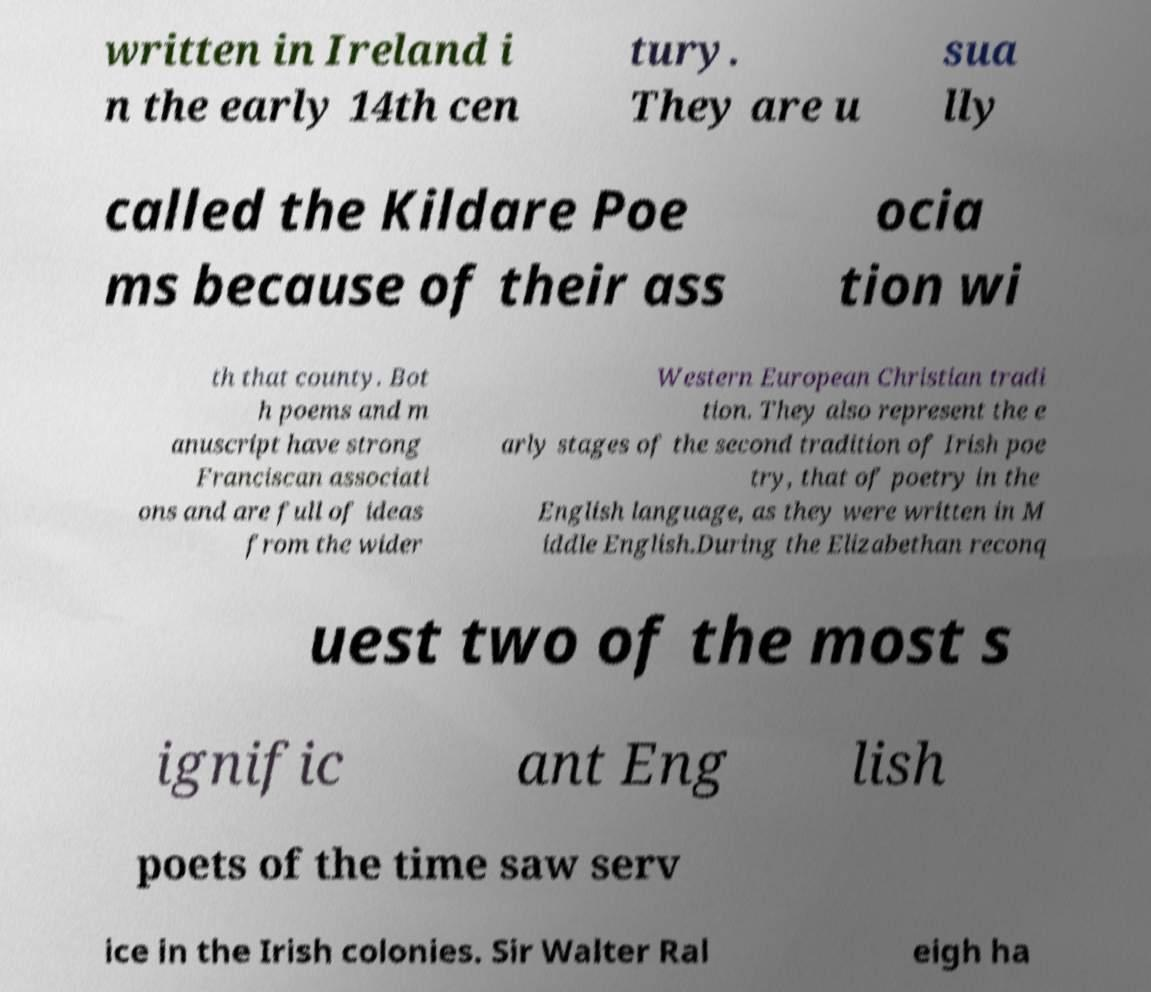Please identify and transcribe the text found in this image. written in Ireland i n the early 14th cen tury. They are u sua lly called the Kildare Poe ms because of their ass ocia tion wi th that county. Bot h poems and m anuscript have strong Franciscan associati ons and are full of ideas from the wider Western European Christian tradi tion. They also represent the e arly stages of the second tradition of Irish poe try, that of poetry in the English language, as they were written in M iddle English.During the Elizabethan reconq uest two of the most s ignific ant Eng lish poets of the time saw serv ice in the Irish colonies. Sir Walter Ral eigh ha 